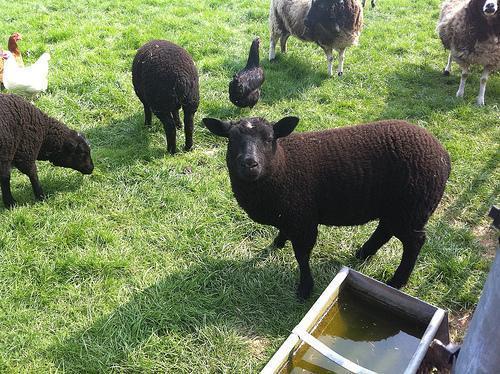How many animals are visible?
Give a very brief answer. 8. How many chickens are there?
Give a very brief answer. 3. 